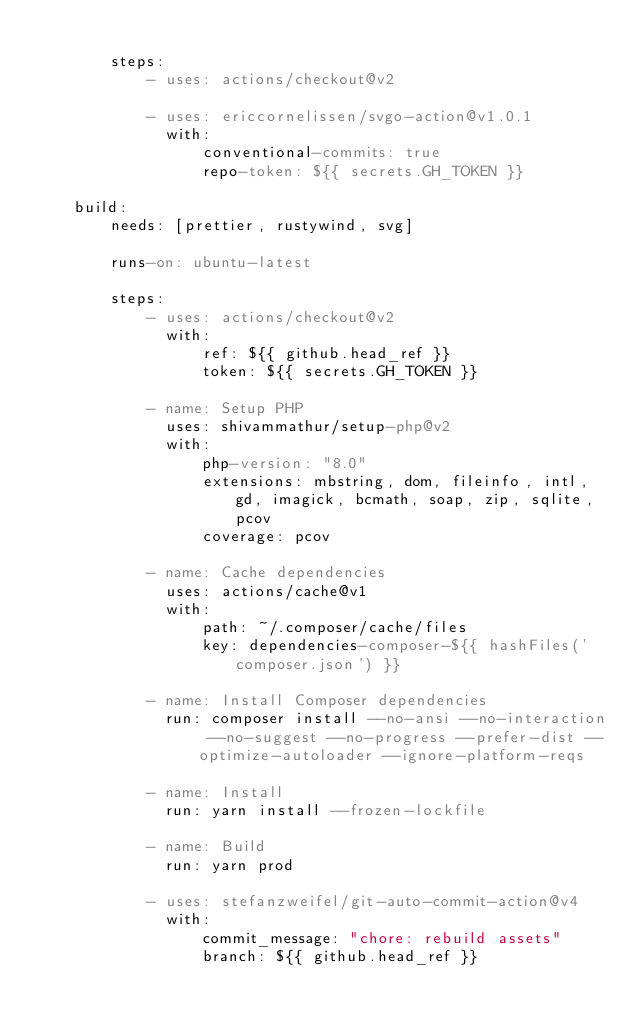<code> <loc_0><loc_0><loc_500><loc_500><_YAML_>
        steps:
            - uses: actions/checkout@v2

            - uses: ericcornelissen/svgo-action@v1.0.1
              with:
                  conventional-commits: true
                  repo-token: ${{ secrets.GH_TOKEN }}

    build:
        needs: [prettier, rustywind, svg]

        runs-on: ubuntu-latest

        steps:
            - uses: actions/checkout@v2
              with:
                  ref: ${{ github.head_ref }}
                  token: ${{ secrets.GH_TOKEN }}

            - name: Setup PHP
              uses: shivammathur/setup-php@v2
              with:
                  php-version: "8.0"
                  extensions: mbstring, dom, fileinfo, intl, gd, imagick, bcmath, soap, zip, sqlite, pcov
                  coverage: pcov

            - name: Cache dependencies
              uses: actions/cache@v1
              with:
                  path: ~/.composer/cache/files
                  key: dependencies-composer-${{ hashFiles('composer.json') }}

            - name: Install Composer dependencies
              run: composer install --no-ansi --no-interaction --no-suggest --no-progress --prefer-dist --optimize-autoloader --ignore-platform-reqs

            - name: Install
              run: yarn install --frozen-lockfile

            - name: Build
              run: yarn prod

            - uses: stefanzweifel/git-auto-commit-action@v4
              with:
                  commit_message: "chore: rebuild assets"
                  branch: ${{ github.head_ref }}
</code> 